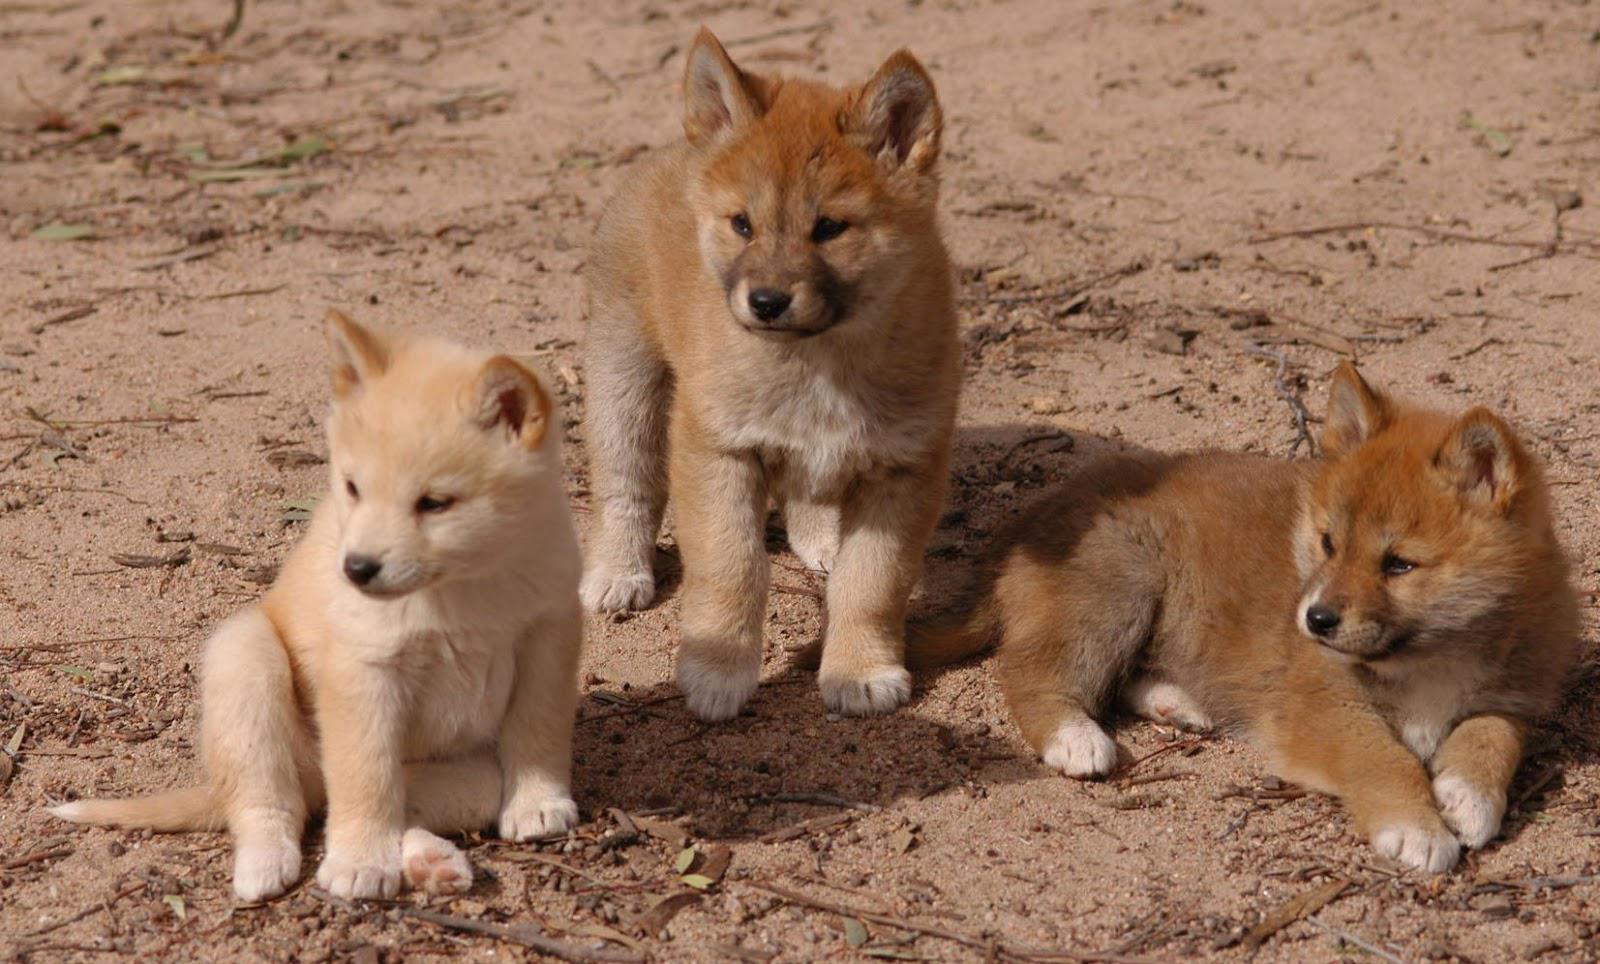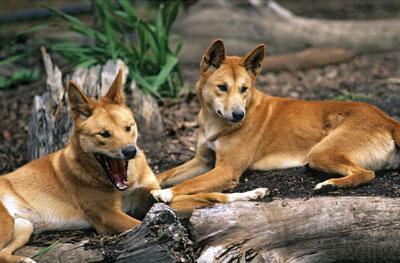The first image is the image on the left, the second image is the image on the right. Given the left and right images, does the statement "An image shows multiple dogs reclining near some type of tree log." hold true? Answer yes or no. Yes. 